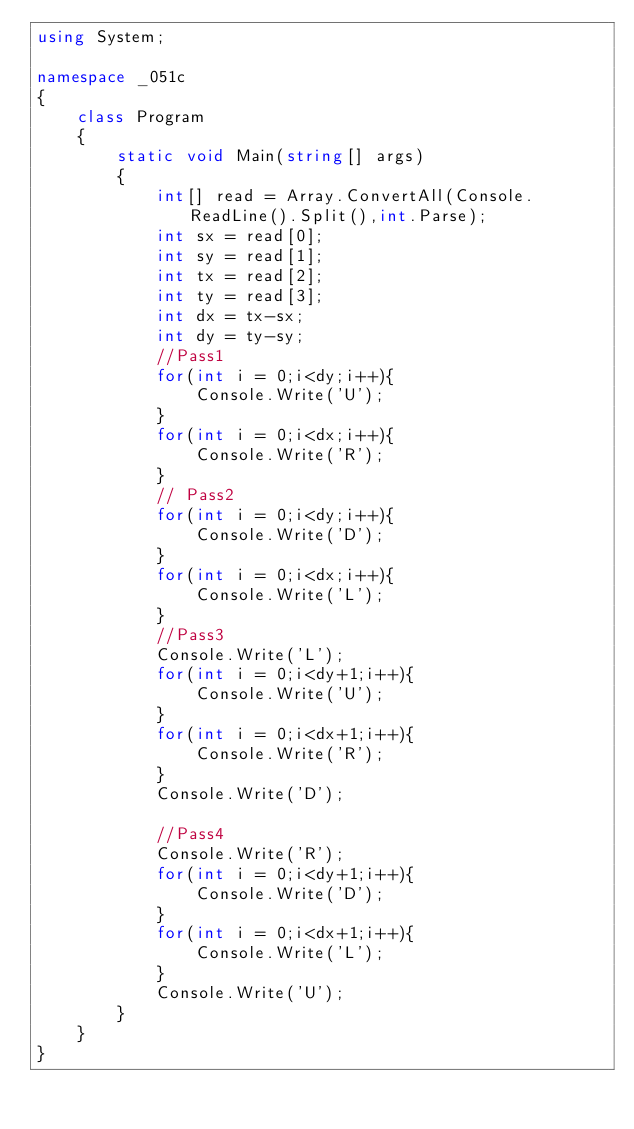<code> <loc_0><loc_0><loc_500><loc_500><_C#_>using System;

namespace _051c
{
    class Program
    {
        static void Main(string[] args)
        {
            int[] read = Array.ConvertAll(Console.ReadLine().Split(),int.Parse);
            int sx = read[0];
            int sy = read[1];
            int tx = read[2];
            int ty = read[3];
            int dx = tx-sx;
            int dy = ty-sy;
            //Pass1
            for(int i = 0;i<dy;i++){
                Console.Write('U');
            }
            for(int i = 0;i<dx;i++){
                Console.Write('R');
            }
            // Pass2
            for(int i = 0;i<dy;i++){
                Console.Write('D');
            }
            for(int i = 0;i<dx;i++){
                Console.Write('L');
            }
            //Pass3
            Console.Write('L');
            for(int i = 0;i<dy+1;i++){
                Console.Write('U');
            }
            for(int i = 0;i<dx+1;i++){
                Console.Write('R');
            }
            Console.Write('D');
            
            //Pass4
            Console.Write('R');
            for(int i = 0;i<dy+1;i++){
                Console.Write('D');
            }
            for(int i = 0;i<dx+1;i++){
                Console.Write('L');
            }
            Console.Write('U');
        }
    }
}</code> 